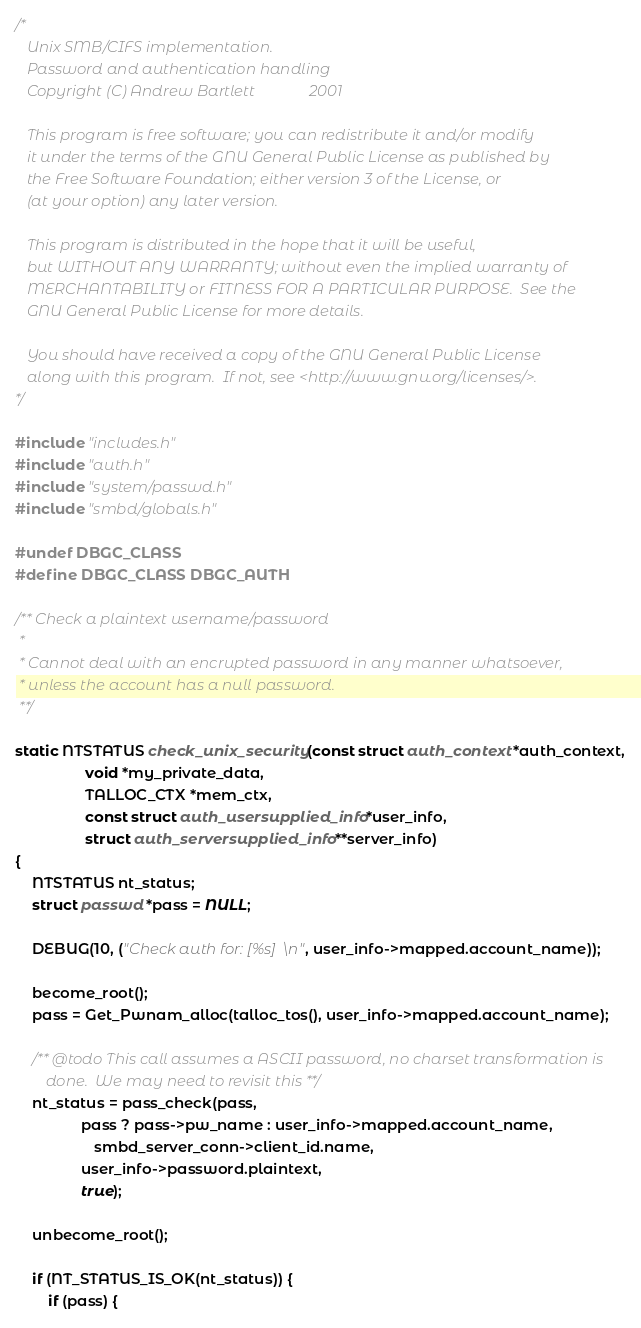<code> <loc_0><loc_0><loc_500><loc_500><_C_>/* 
   Unix SMB/CIFS implementation.
   Password and authentication handling
   Copyright (C) Andrew Bartlett              2001

   This program is free software; you can redistribute it and/or modify
   it under the terms of the GNU General Public License as published by
   the Free Software Foundation; either version 3 of the License, or
   (at your option) any later version.

   This program is distributed in the hope that it will be useful,
   but WITHOUT ANY WARRANTY; without even the implied warranty of
   MERCHANTABILITY or FITNESS FOR A PARTICULAR PURPOSE.  See the
   GNU General Public License for more details.

   You should have received a copy of the GNU General Public License
   along with this program.  If not, see <http://www.gnu.org/licenses/>.
*/

#include "includes.h"
#include "auth.h"
#include "system/passwd.h"
#include "smbd/globals.h"

#undef DBGC_CLASS
#define DBGC_CLASS DBGC_AUTH

/** Check a plaintext username/password
 *
 * Cannot deal with an encrupted password in any manner whatsoever,
 * unless the account has a null password.
 **/

static NTSTATUS check_unix_security(const struct auth_context *auth_context,
			     void *my_private_data, 
			     TALLOC_CTX *mem_ctx,
			     const struct auth_usersupplied_info *user_info,
			     struct auth_serversupplied_info **server_info)
{
	NTSTATUS nt_status;
	struct passwd *pass = NULL;

	DEBUG(10, ("Check auth for: [%s]\n", user_info->mapped.account_name));

	become_root();
	pass = Get_Pwnam_alloc(talloc_tos(), user_info->mapped.account_name);

	/** @todo This call assumes a ASCII password, no charset transformation is 
	    done.  We may need to revisit this **/
	nt_status = pass_check(pass,
				pass ? pass->pw_name : user_info->mapped.account_name,
			       smbd_server_conn->client_id.name,
				user_info->password.plaintext,
				true);

	unbecome_root();

	if (NT_STATUS_IS_OK(nt_status)) {
		if (pass) {</code> 